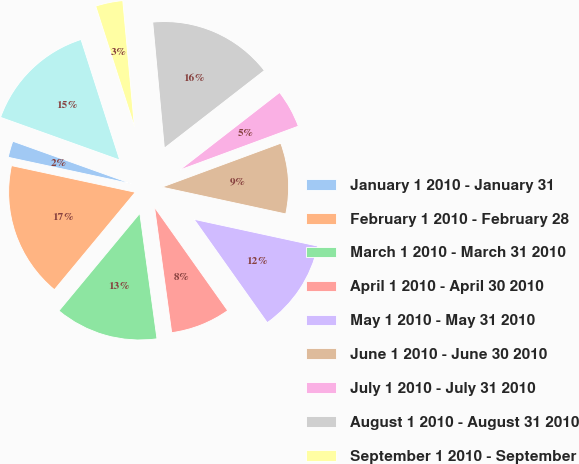Convert chart. <chart><loc_0><loc_0><loc_500><loc_500><pie_chart><fcel>January 1 2010 - January 31<fcel>February 1 2010 - February 28<fcel>March 1 2010 - March 31 2010<fcel>April 1 2010 - April 30 2010<fcel>May 1 2010 - May 31 2010<fcel>June 1 2010 - June 30 2010<fcel>July 1 2010 - July 31 2010<fcel>August 1 2010 - August 31 2010<fcel>September 1 2010 - September<fcel>October 1 2010 - October 31<nl><fcel>2.1%<fcel>17.35%<fcel>13.19%<fcel>7.64%<fcel>11.8%<fcel>9.03%<fcel>4.87%<fcel>15.96%<fcel>3.48%<fcel>14.58%<nl></chart> 